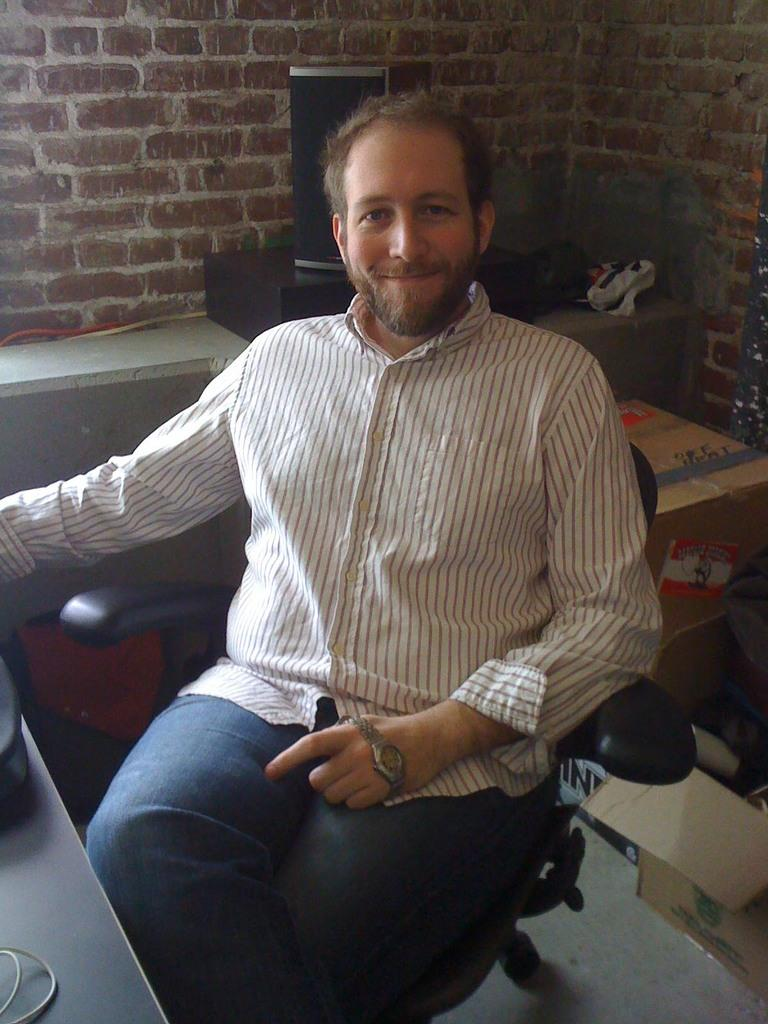Who is present in the image? There is a man in the image. What is the man doing in the image? The man is sitting on a chair. How does the man appear in the image? The man has a smile on his face. What can be seen in the background of the image? There are boxes in the background of the image. What type of cord is being used by the man in the image? There is no cord visible in the image; the man is simply sitting on a chair with a smile on his face. 